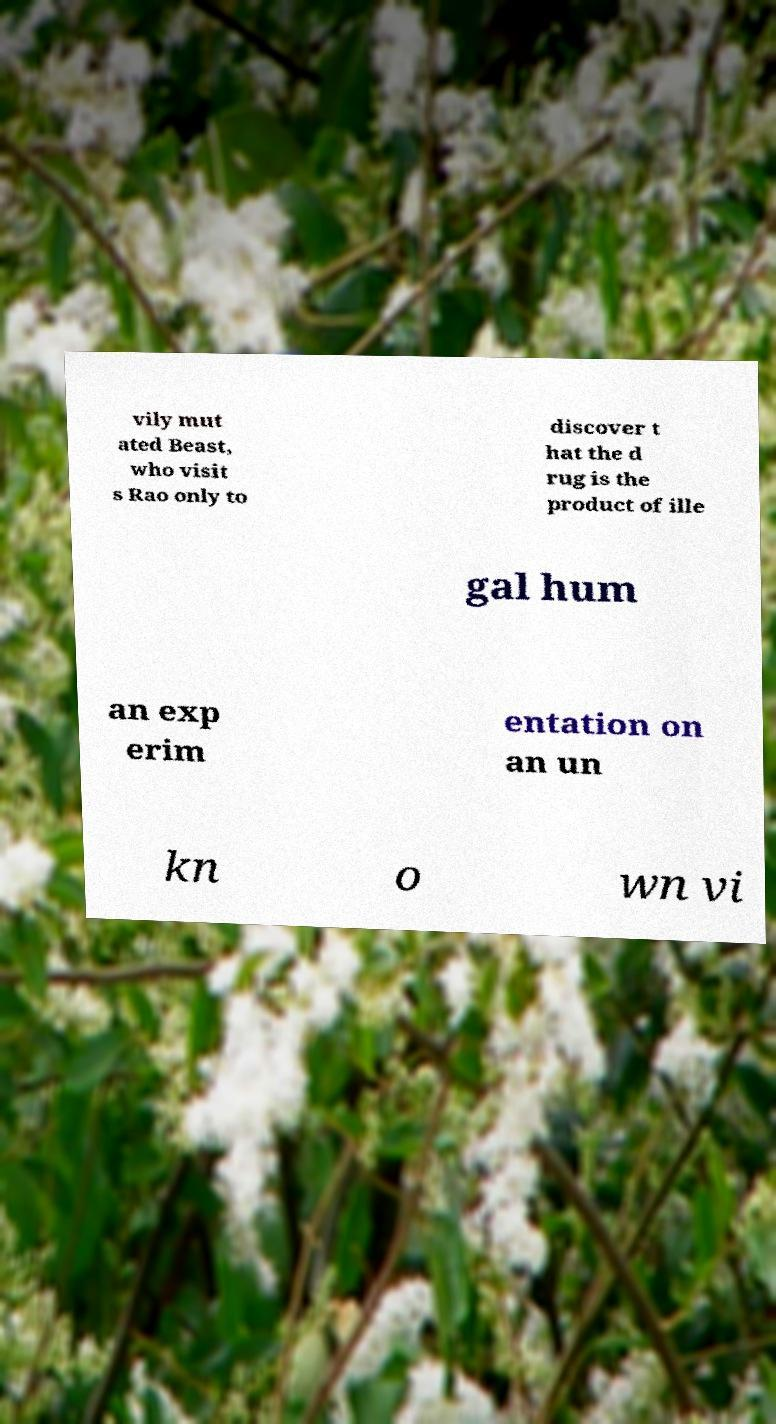Could you extract and type out the text from this image? vily mut ated Beast, who visit s Rao only to discover t hat the d rug is the product of ille gal hum an exp erim entation on an un kn o wn vi 